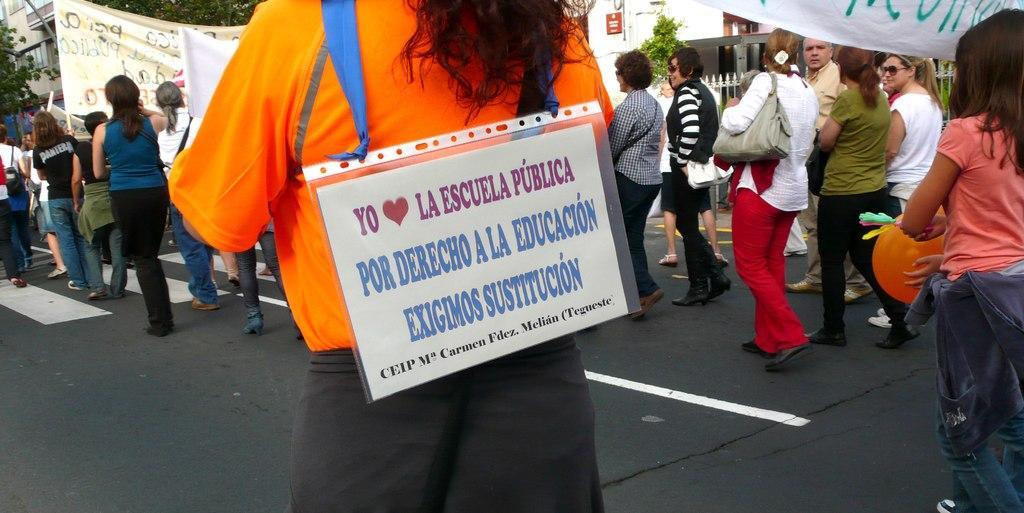How would you summarize this image in a sentence or two? This image consists of many persons walking on the road. They are holding banners and placards. In the background, we can see trees and buildings along with fencing. 